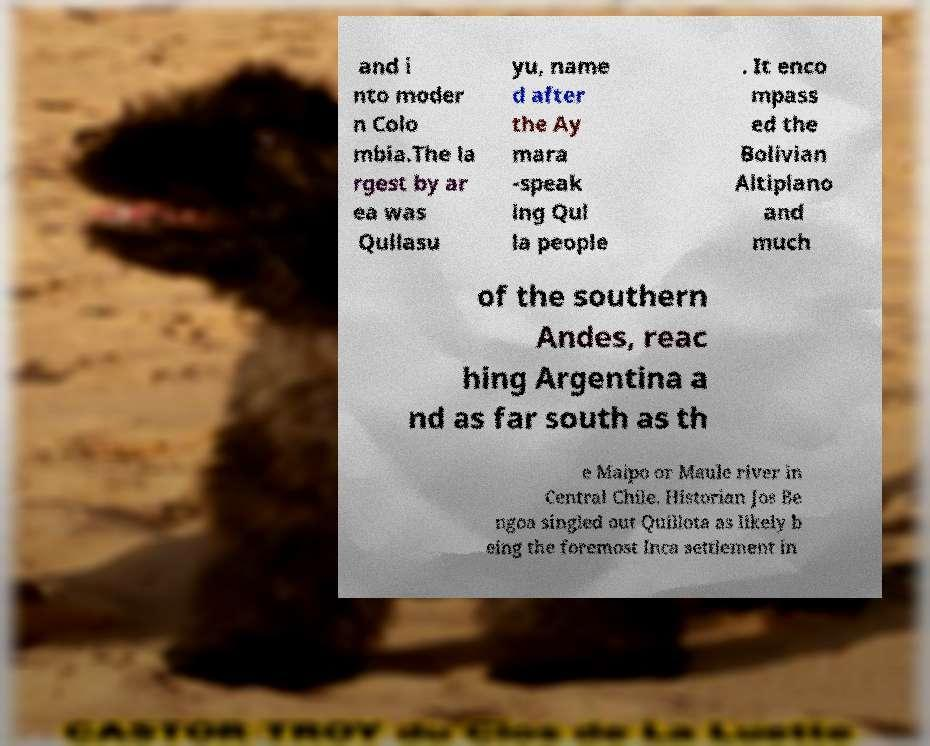Could you assist in decoding the text presented in this image and type it out clearly? and i nto moder n Colo mbia.The la rgest by ar ea was Qullasu yu, name d after the Ay mara -speak ing Qul la people . It enco mpass ed the Bolivian Altiplano and much of the southern Andes, reac hing Argentina a nd as far south as th e Maipo or Maule river in Central Chile. Historian Jos Be ngoa singled out Quillota as likely b eing the foremost Inca settlement in 